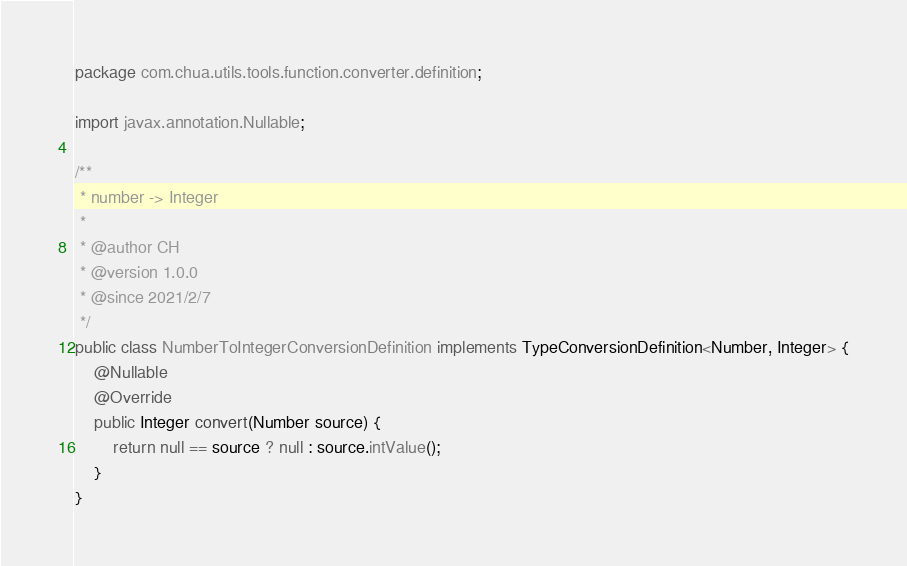Convert code to text. <code><loc_0><loc_0><loc_500><loc_500><_Java_>package com.chua.utils.tools.function.converter.definition;

import javax.annotation.Nullable;

/**
 * number -> Integer
 *
 * @author CH
 * @version 1.0.0
 * @since 2021/2/7
 */
public class NumberToIntegerConversionDefinition implements TypeConversionDefinition<Number, Integer> {
    @Nullable
    @Override
    public Integer convert(Number source) {
        return null == source ? null : source.intValue();
    }
}
</code> 